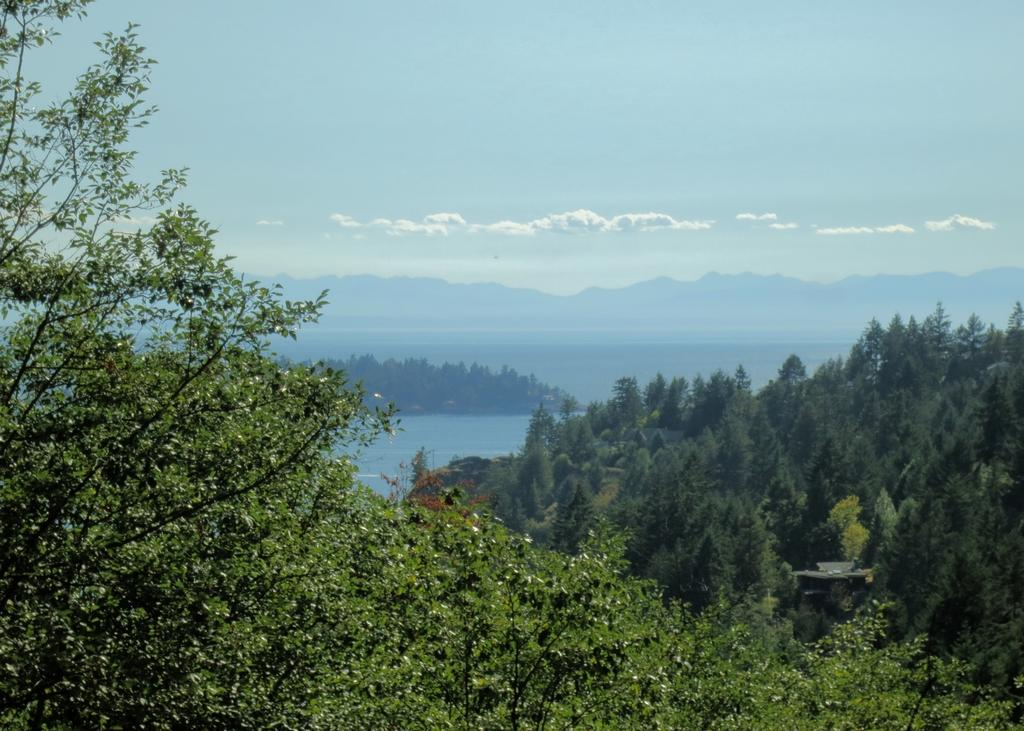What is present on both sides of the image? There are many balloons on both sides of the image. What can be seen in the background of the image? Water and the sky are visible in the background of the image. What is the condition of the sky in the image? Clouds are present in the sky. What type of vase can be seen floating on the water in the image? There is no vase present in the image; it features many balloons and a sky with clouds. 